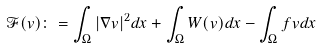Convert formula to latex. <formula><loc_0><loc_0><loc_500><loc_500>\mathcal { F } ( v ) \colon = \int _ { \Omega } | \nabla v | ^ { 2 } d x + \int _ { \Omega } W ( v ) d x - \int _ { \Omega } f v d x</formula> 